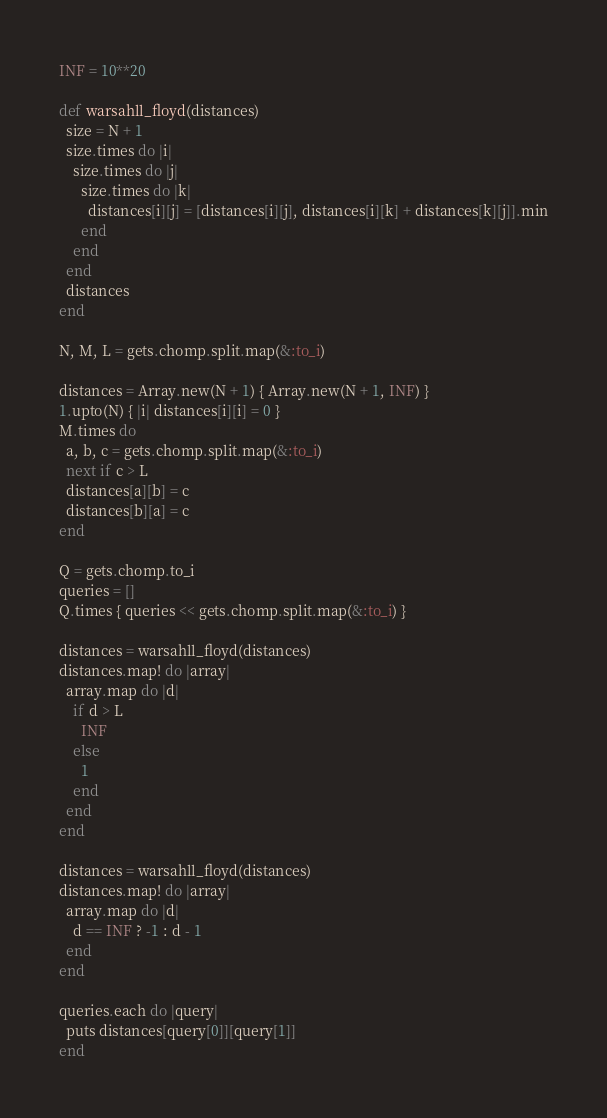Convert code to text. <code><loc_0><loc_0><loc_500><loc_500><_Ruby_>INF = 10**20

def warsahll_floyd(distances)
  size = N + 1
  size.times do |i|
    size.times do |j|
      size.times do |k|
        distances[i][j] = [distances[i][j], distances[i][k] + distances[k][j]].min
      end
    end
  end
  distances
end

N, M, L = gets.chomp.split.map(&:to_i)

distances = Array.new(N + 1) { Array.new(N + 1, INF) }
1.upto(N) { |i| distances[i][i] = 0 }
M.times do
  a, b, c = gets.chomp.split.map(&:to_i)
  next if c > L
  distances[a][b] = c
  distances[b][a] = c
end

Q = gets.chomp.to_i
queries = []
Q.times { queries << gets.chomp.split.map(&:to_i) }

distances = warsahll_floyd(distances)
distances.map! do |array|
  array.map do |d|
    if d > L
      INF
    else
      1
    end
  end
end

distances = warsahll_floyd(distances)
distances.map! do |array|
  array.map do |d|
    d == INF ? -1 : d - 1
  end
end

queries.each do |query|
  puts distances[query[0]][query[1]]
end
</code> 